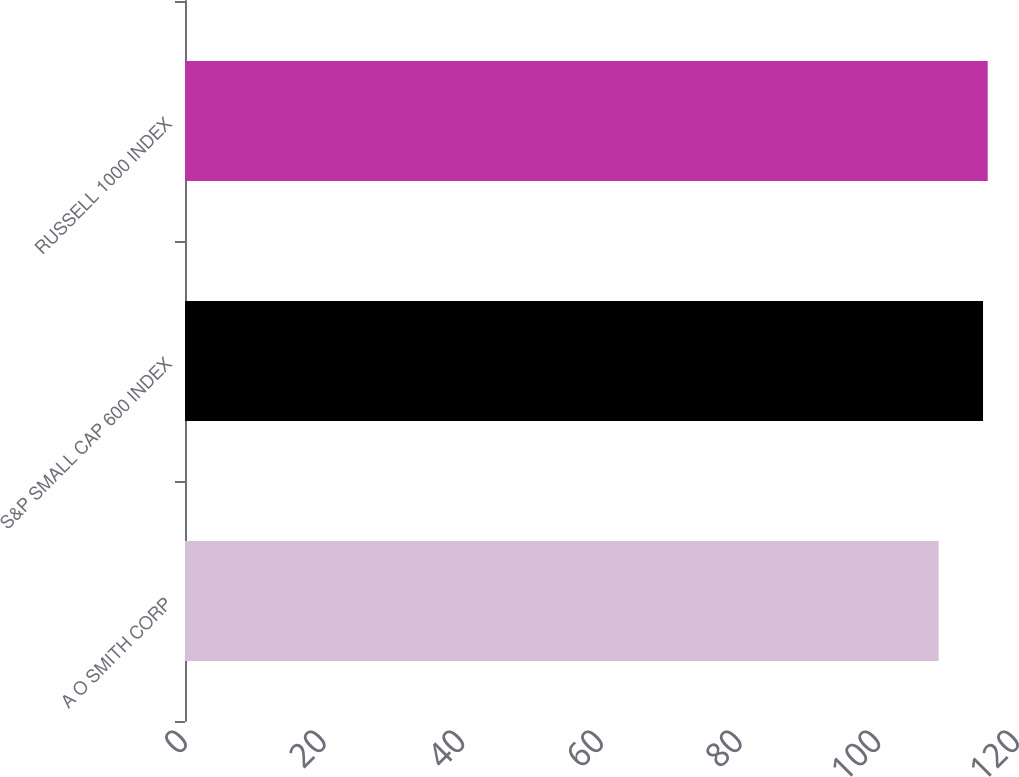Convert chart. <chart><loc_0><loc_0><loc_500><loc_500><bar_chart><fcel>A O SMITH CORP<fcel>S&P SMALL CAP 600 INDEX<fcel>RUSSELL 1000 INDEX<nl><fcel>108.7<fcel>115.1<fcel>115.78<nl></chart> 